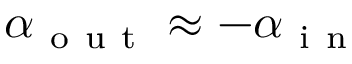<formula> <loc_0><loc_0><loc_500><loc_500>\alpha _ { o u t } \approx - \alpha _ { i n }</formula> 